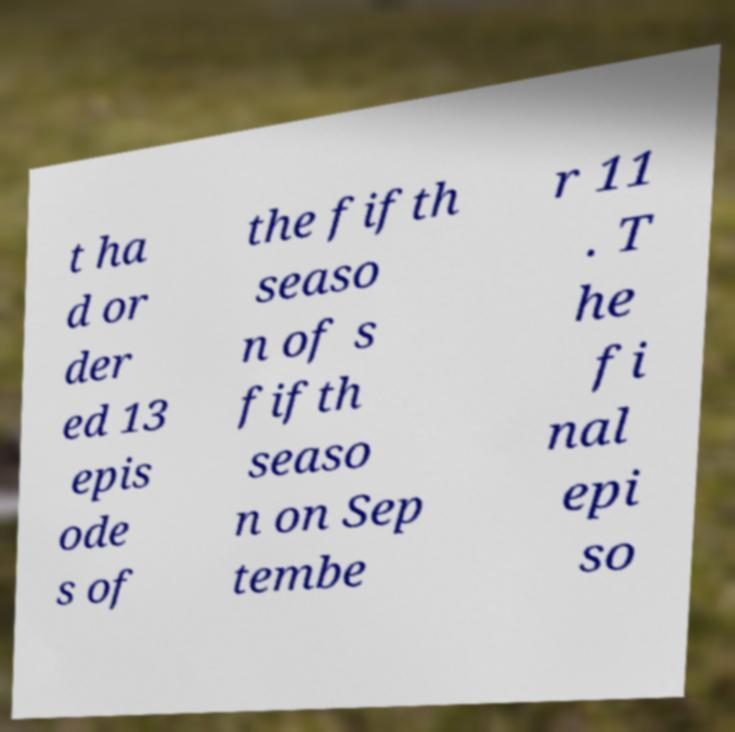Can you read and provide the text displayed in the image?This photo seems to have some interesting text. Can you extract and type it out for me? t ha d or der ed 13 epis ode s of the fifth seaso n of s fifth seaso n on Sep tembe r 11 . T he fi nal epi so 